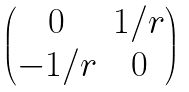<formula> <loc_0><loc_0><loc_500><loc_500>\begin{pmatrix} 0 & 1 / r \\ - 1 / r & 0 \end{pmatrix}</formula> 